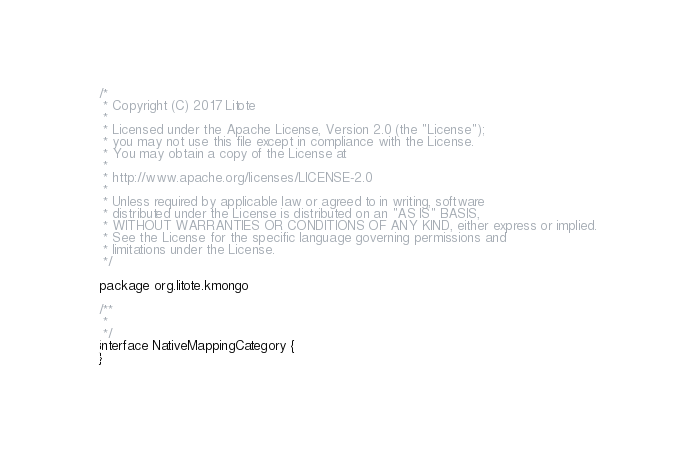Convert code to text. <code><loc_0><loc_0><loc_500><loc_500><_Kotlin_>/*
 * Copyright (C) 2017 Litote
 *
 * Licensed under the Apache License, Version 2.0 (the "License");
 * you may not use this file except in compliance with the License.
 * You may obtain a copy of the License at
 *
 * http://www.apache.org/licenses/LICENSE-2.0
 *
 * Unless required by applicable law or agreed to in writing, software
 * distributed under the License is distributed on an "AS IS" BASIS,
 * WITHOUT WARRANTIES OR CONDITIONS OF ANY KIND, either express or implied.
 * See the License for the specific language governing permissions and
 * limitations under the License.
 */

package org.litote.kmongo

/**
 *
 */
interface NativeMappingCategory {
}</code> 